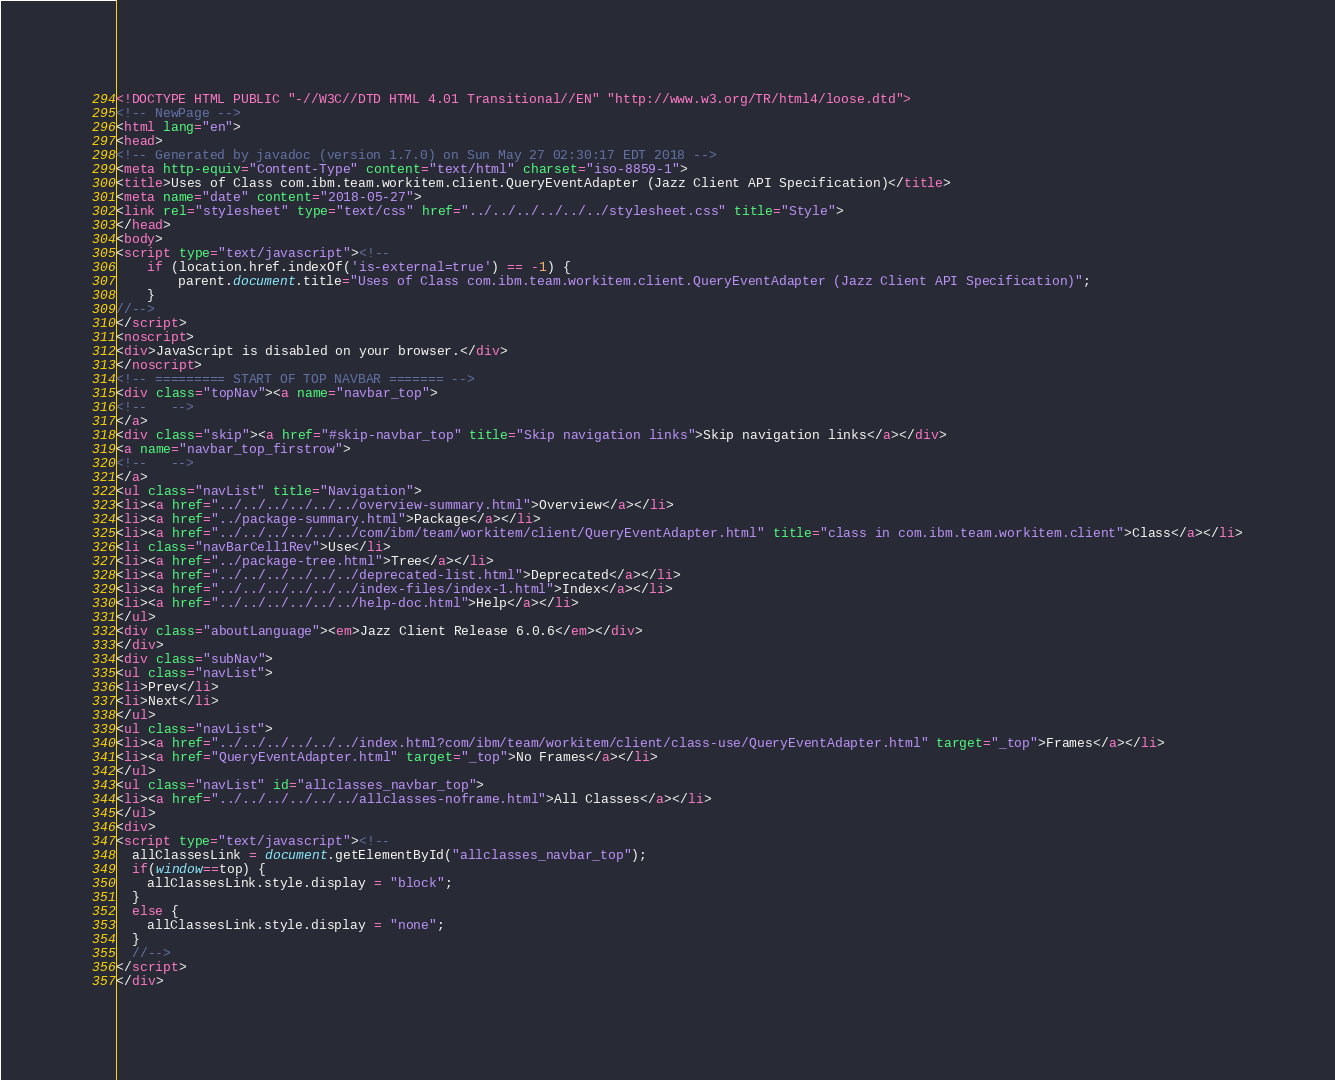<code> <loc_0><loc_0><loc_500><loc_500><_HTML_><!DOCTYPE HTML PUBLIC "-//W3C//DTD HTML 4.01 Transitional//EN" "http://www.w3.org/TR/html4/loose.dtd">
<!-- NewPage -->
<html lang="en">
<head>
<!-- Generated by javadoc (version 1.7.0) on Sun May 27 02:30:17 EDT 2018 -->
<meta http-equiv="Content-Type" content="text/html" charset="iso-8859-1">
<title>Uses of Class com.ibm.team.workitem.client.QueryEventAdapter (Jazz Client API Specification)</title>
<meta name="date" content="2018-05-27">
<link rel="stylesheet" type="text/css" href="../../../../../../stylesheet.css" title="Style">
</head>
<body>
<script type="text/javascript"><!--
    if (location.href.indexOf('is-external=true') == -1) {
        parent.document.title="Uses of Class com.ibm.team.workitem.client.QueryEventAdapter (Jazz Client API Specification)";
    }
//-->
</script>
<noscript>
<div>JavaScript is disabled on your browser.</div>
</noscript>
<!-- ========= START OF TOP NAVBAR ======= -->
<div class="topNav"><a name="navbar_top">
<!--   -->
</a>
<div class="skip"><a href="#skip-navbar_top" title="Skip navigation links">Skip navigation links</a></div>
<a name="navbar_top_firstrow">
<!--   -->
</a>
<ul class="navList" title="Navigation">
<li><a href="../../../../../../overview-summary.html">Overview</a></li>
<li><a href="../package-summary.html">Package</a></li>
<li><a href="../../../../../../com/ibm/team/workitem/client/QueryEventAdapter.html" title="class in com.ibm.team.workitem.client">Class</a></li>
<li class="navBarCell1Rev">Use</li>
<li><a href="../package-tree.html">Tree</a></li>
<li><a href="../../../../../../deprecated-list.html">Deprecated</a></li>
<li><a href="../../../../../../index-files/index-1.html">Index</a></li>
<li><a href="../../../../../../help-doc.html">Help</a></li>
</ul>
<div class="aboutLanguage"><em>Jazz Client Release 6.0.6</em></div>
</div>
<div class="subNav">
<ul class="navList">
<li>Prev</li>
<li>Next</li>
</ul>
<ul class="navList">
<li><a href="../../../../../../index.html?com/ibm/team/workitem/client/class-use/QueryEventAdapter.html" target="_top">Frames</a></li>
<li><a href="QueryEventAdapter.html" target="_top">No Frames</a></li>
</ul>
<ul class="navList" id="allclasses_navbar_top">
<li><a href="../../../../../../allclasses-noframe.html">All Classes</a></li>
</ul>
<div>
<script type="text/javascript"><!--
  allClassesLink = document.getElementById("allclasses_navbar_top");
  if(window==top) {
    allClassesLink.style.display = "block";
  }
  else {
    allClassesLink.style.display = "none";
  }
  //-->
</script>
</div></code> 